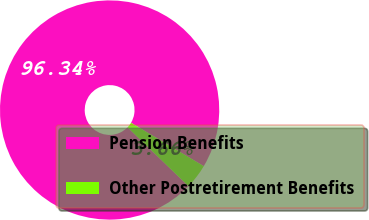Convert chart to OTSL. <chart><loc_0><loc_0><loc_500><loc_500><pie_chart><fcel>Pension Benefits<fcel>Other Postretirement Benefits<nl><fcel>96.34%<fcel>3.66%<nl></chart> 